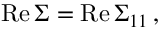Convert formula to latex. <formula><loc_0><loc_0><loc_500><loc_500>R e \, \Sigma = R e \, { \Sigma } _ { 1 1 } \, ,</formula> 